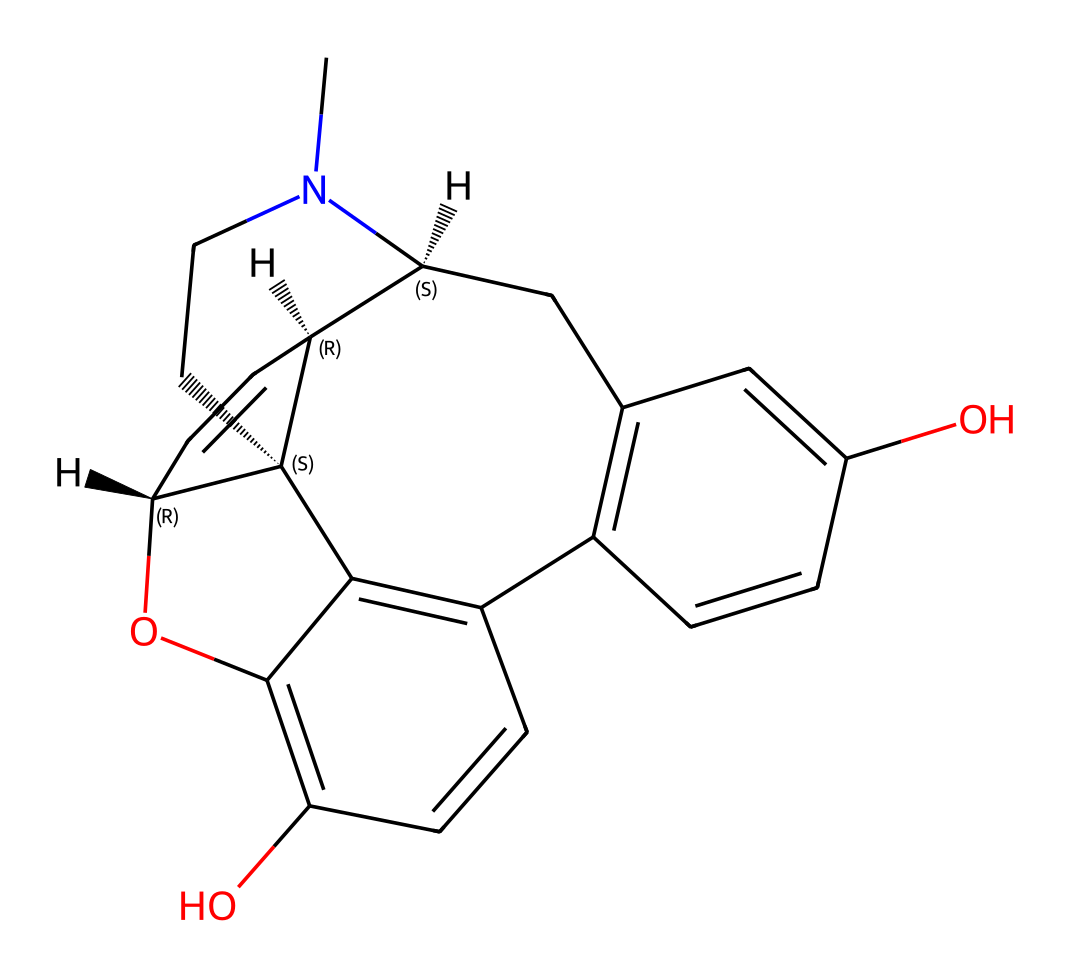How many carbon atoms are present in the molecule? By analyzing the SMILES representation, each 'C' character indicates a carbon atom. Counting the occurrences results in a total of 22 carbon atoms.
Answer: 22 How many hydroxyl (–OH) groups are present in the structure? The hydroxyl groups can be identified by looking for 'O' followed by a hydrogen atom in the representation. There are two instances where this occurs in the chemical structure, indicating the presence of two hydroxyl groups.
Answer: 2 What is the molecular formula of the compound? The molecular formula is derived from counting all the atoms in the SMILES notation, which results in C22H27N2O2.
Answer: C22H27N2O2 Which part of the structure is responsible for the analgesic effect? The nitrogen atom is typically a key characteristic in opioid analgesics, as it connects to other components in the structure that interact with opioid receptors, making it crucial for the analgesic effect.
Answer: nitrogen What type of chemical bond connects the carbon atoms in this molecule? The connections between carbon atoms are primarily covalent bonds, characterized by shared electron pairs. In the representation, the connections can be inferred from how carbon atoms are arranged and connected in the structure.
Answer: covalent bonds What is the stereochemistry of this compound? Stereochemistry can be determined by the presence of chiral centers in the structure, indicated by '@' symbols in the SMILES representation. There are three chiral centers present in this chemical structure.
Answer: 3 Does this molecule contain any ring structures? By examining the SMILES representation, it can be observed that there are cyclic formations indicated by the numeric markers that denote the closure of cycles, suggesting that this molecule has multiple ring structures.
Answer: yes 